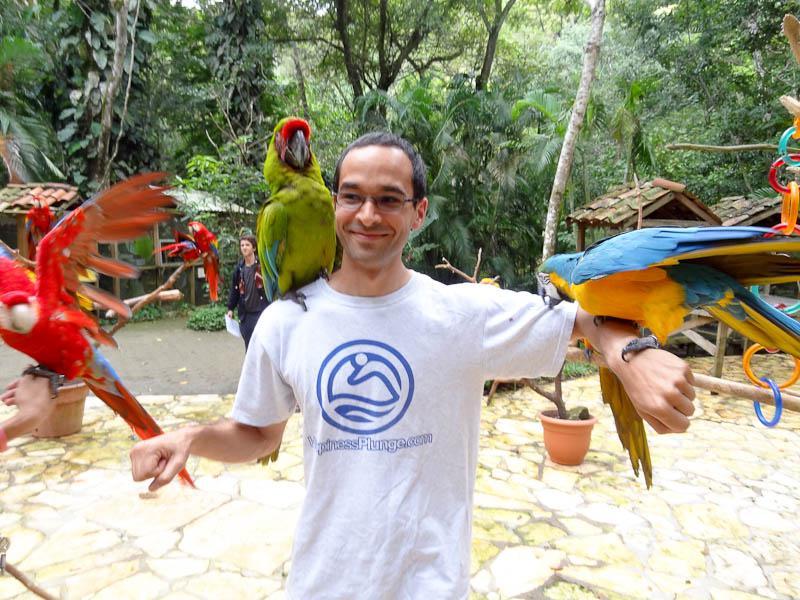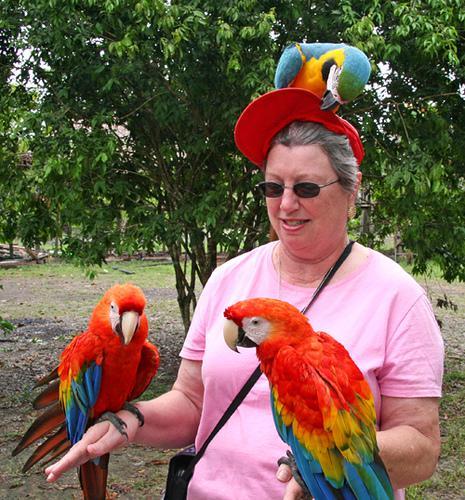The first image is the image on the left, the second image is the image on the right. For the images displayed, is the sentence "On both pictures, parrots can be seen perched on a human, one on each arm and one on a shoulder." factually correct? Answer yes or no. No. 